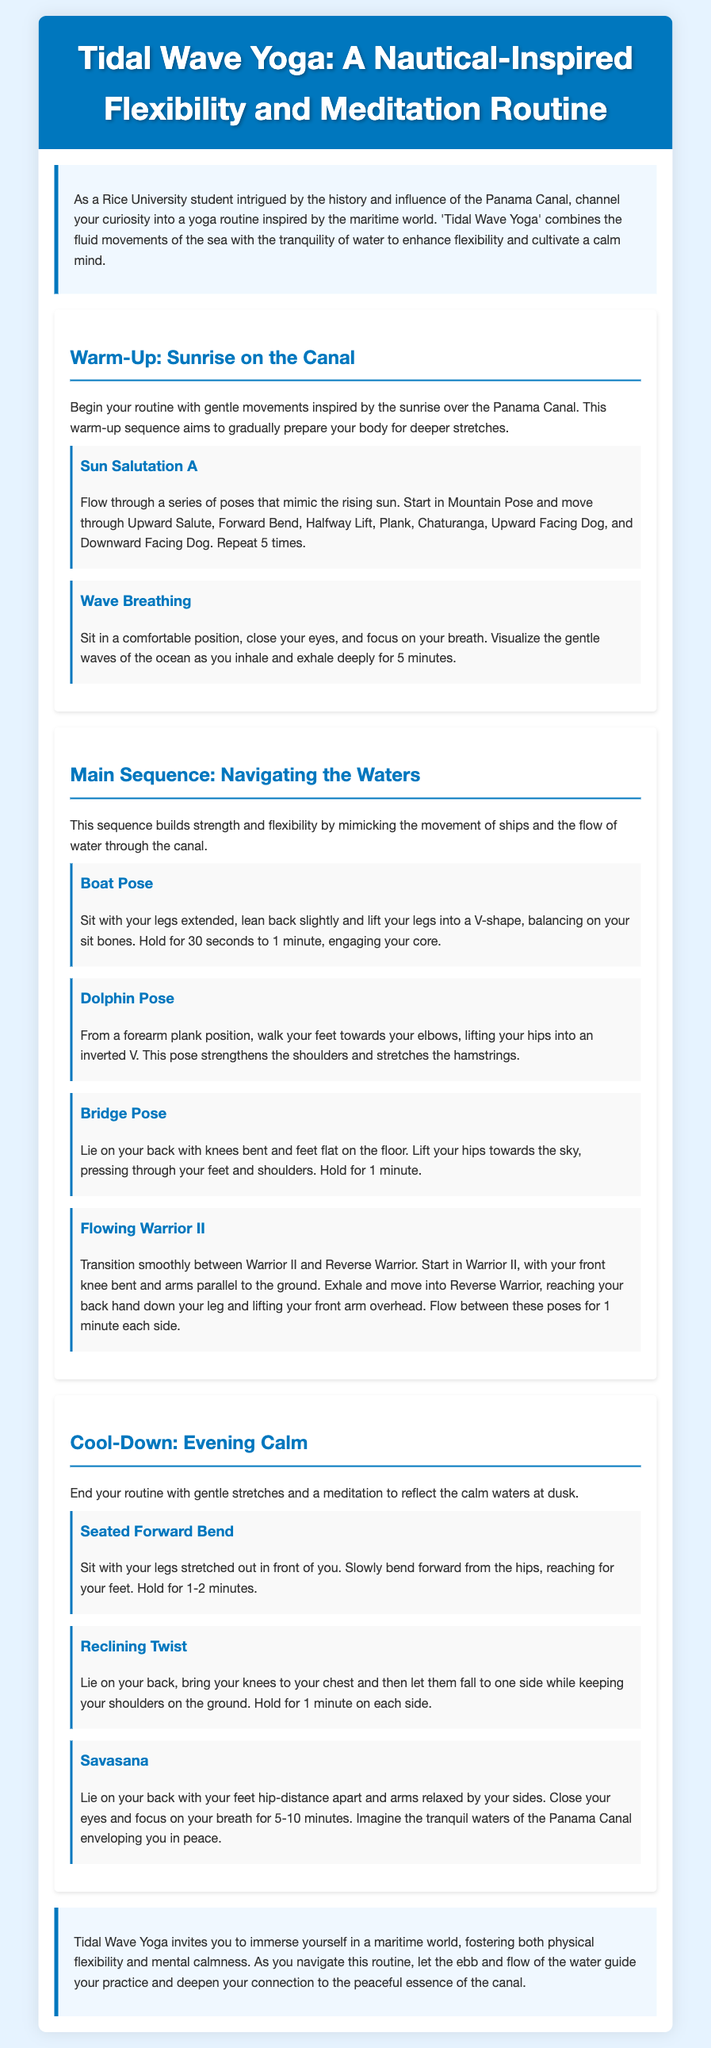What is the title of the yoga routine? The title of the yoga routine is found in the header section of the document.
Answer: Tidal Wave Yoga: A Nautical-Inspired Flexibility and Meditation Routine Who is the intended audience for this yoga routine? The intended audience is specified in the introduction of the document.
Answer: Rice University students How long should you hold the Boat Pose? The duration for holding the Boat Pose is mentioned in the exercise description.
Answer: 30 seconds to 1 minute What breathing technique is suggested in the warm-up? The warm-up section lists a specific breathing exercise.
Answer: Wave Breathing What is the purpose of Tidal Wave Yoga? The purpose is described in the introduction and conclusion sections of the document.
Answer: Enhance flexibility and cultivate a calm mind List one pose included in the Cool-Down section. The Cool-Down section provides multiple exercises, asking for any one of them.
Answer: Seated Forward Bend How many times should the Sun Salutation A be repeated? The number of repetitions for the Sun Salutation A is specified in the warm-up section.
Answer: 5 times What type of yoga pose is Dolphin Pose? Dolphin Pose is categorized based on its position and movement described in the document.
Answer: Strengthening pose 